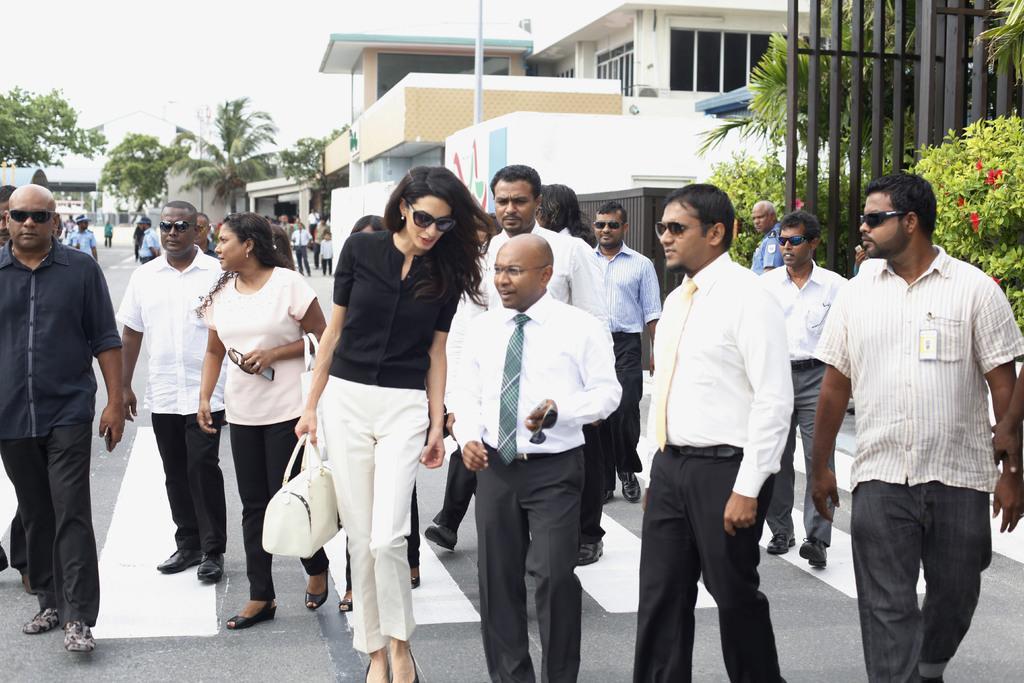In one or two sentences, can you explain what this image depicts? In the middle of the image few people are standing and walking. Behind them there are some trees and poles and buildings. At the top of the image there is sky. 